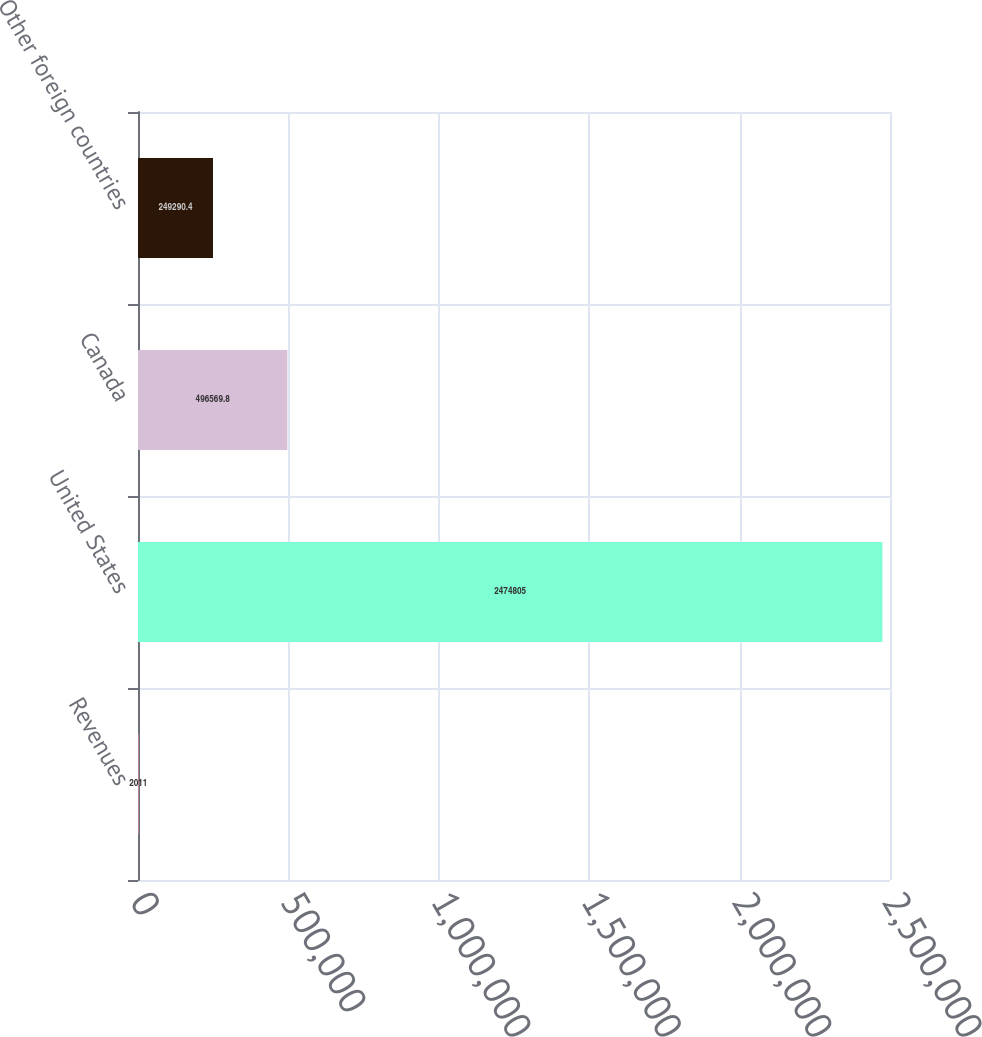Convert chart to OTSL. <chart><loc_0><loc_0><loc_500><loc_500><bar_chart><fcel>Revenues<fcel>United States<fcel>Canada<fcel>Other foreign countries<nl><fcel>2011<fcel>2.4748e+06<fcel>496570<fcel>249290<nl></chart> 